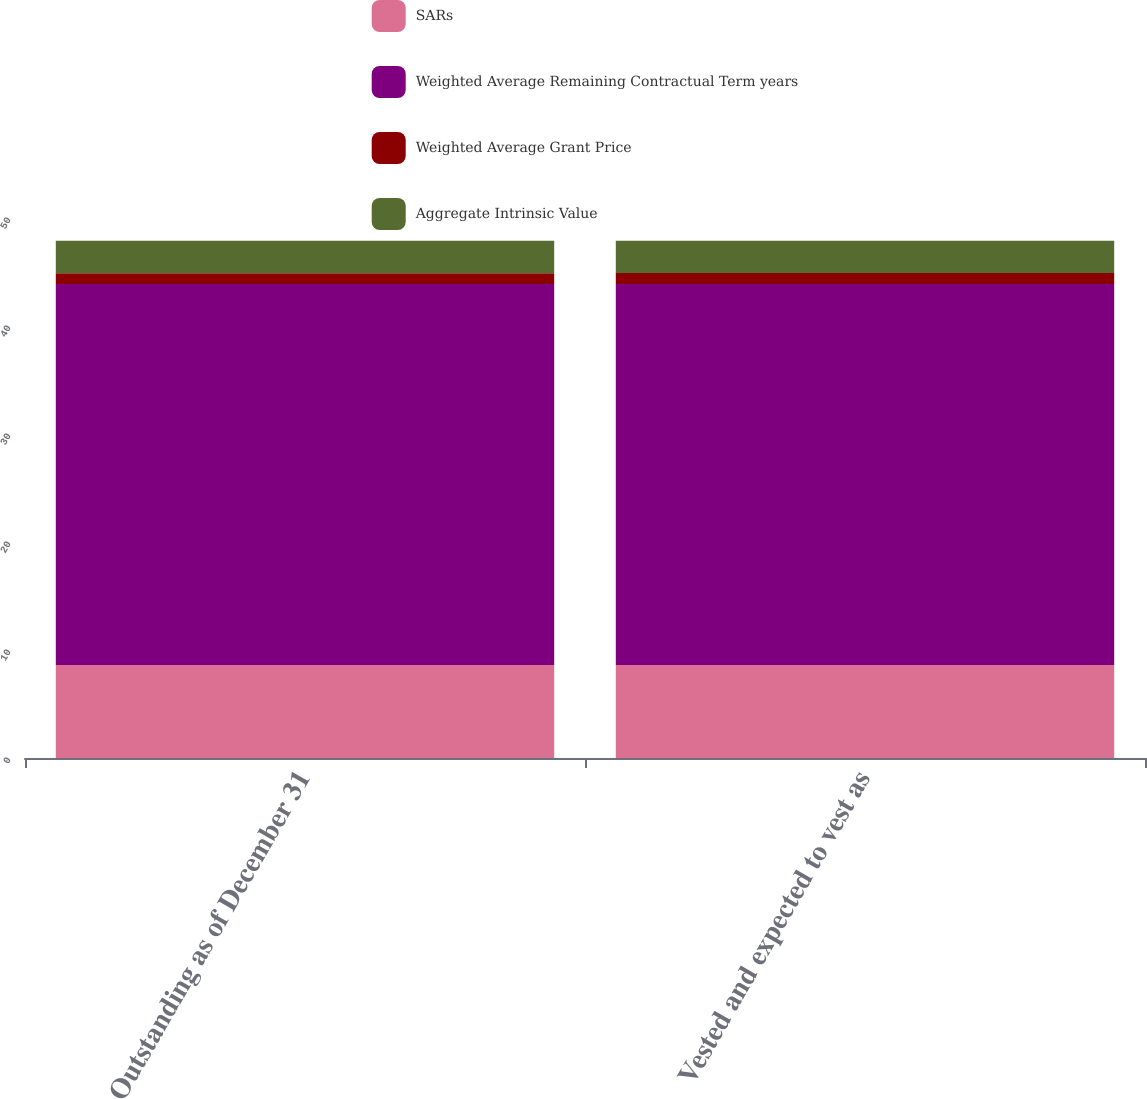<chart> <loc_0><loc_0><loc_500><loc_500><stacked_bar_chart><ecel><fcel>Outstanding as of December 31<fcel>Vested and expected to vest as<nl><fcel>SARs<fcel>8.6<fcel>8.6<nl><fcel>Weighted Average Remaining Contractual Term years<fcel>35.29<fcel>35.3<nl><fcel>Weighted Average Grant Price<fcel>1<fcel>1<nl><fcel>Aggregate Intrinsic Value<fcel>3<fcel>3<nl></chart> 